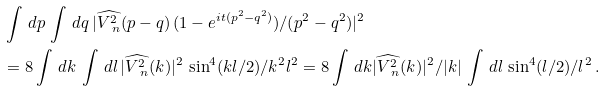<formula> <loc_0><loc_0><loc_500><loc_500>& \int \, d p \, \int \, d q \, | \widehat { V ^ { 2 } _ { \ n } } ( p - q ) \, ( 1 - e ^ { i t ( p ^ { 2 } - q ^ { 2 } ) } ) / ( p ^ { 2 } - q ^ { 2 } ) | ^ { 2 } \\ & = 8 \int \, d k \, \int \, d l \, | \widehat { V ^ { 2 } _ { \ n } } ( k ) | ^ { 2 } \, \sin ^ { 4 } ( k l / 2 ) / k ^ { 2 } l ^ { 2 } = 8 \int \, d k | \widehat { V ^ { 2 } _ { \ n } } ( k ) | ^ { 2 } / | k | \, \int \, d l \, \sin ^ { 4 } ( l / 2 ) / l ^ { 2 } \, .</formula> 